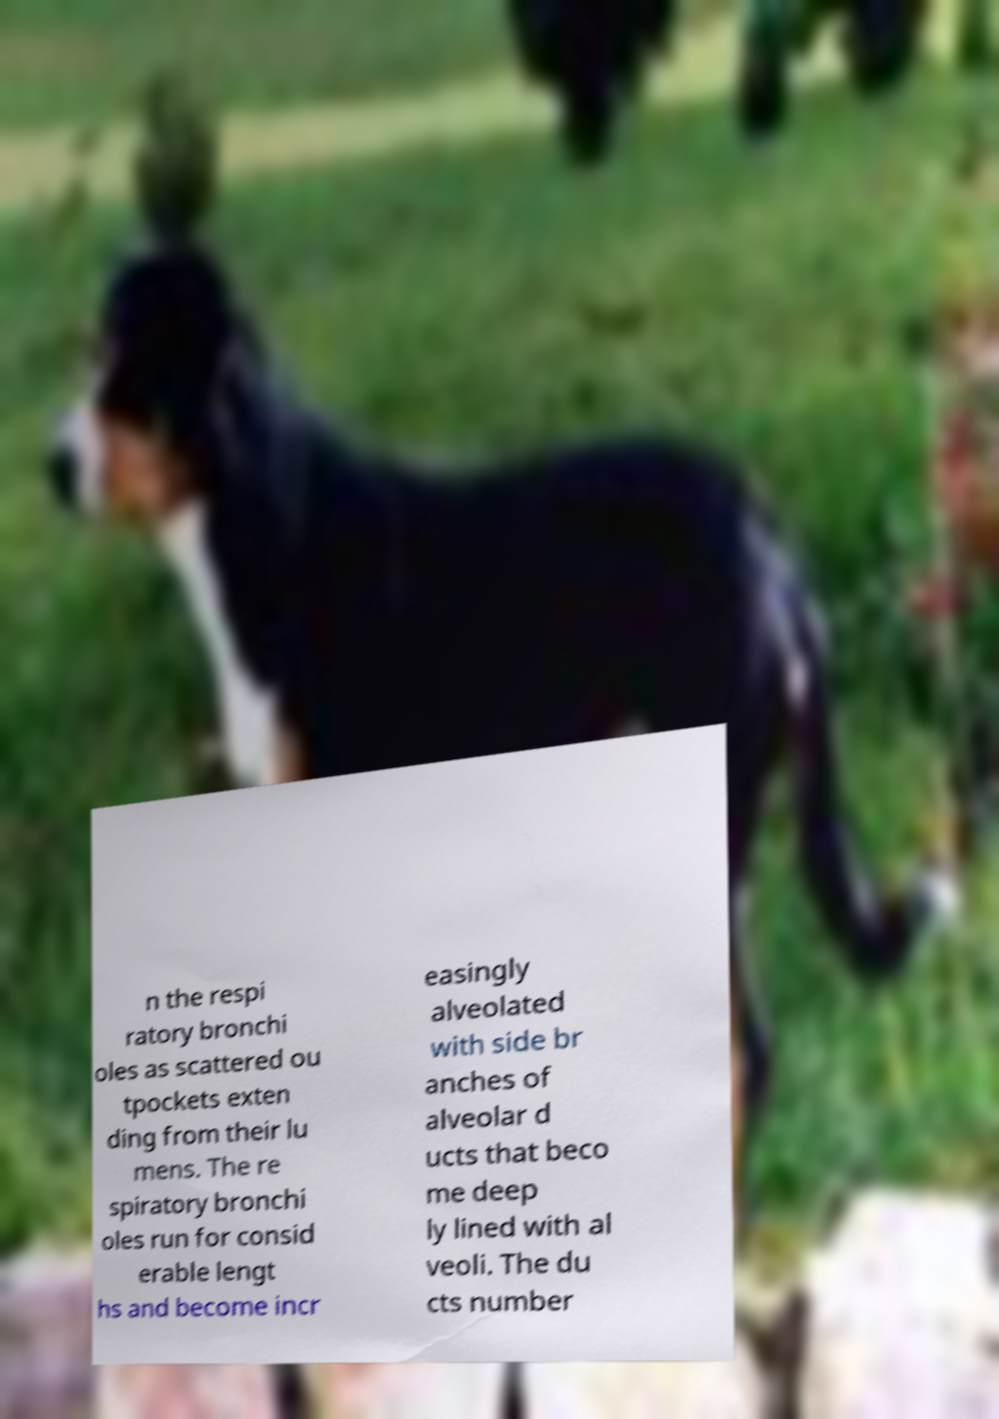Can you accurately transcribe the text from the provided image for me? n the respi ratory bronchi oles as scattered ou tpockets exten ding from their lu mens. The re spiratory bronchi oles run for consid erable lengt hs and become incr easingly alveolated with side br anches of alveolar d ucts that beco me deep ly lined with al veoli. The du cts number 